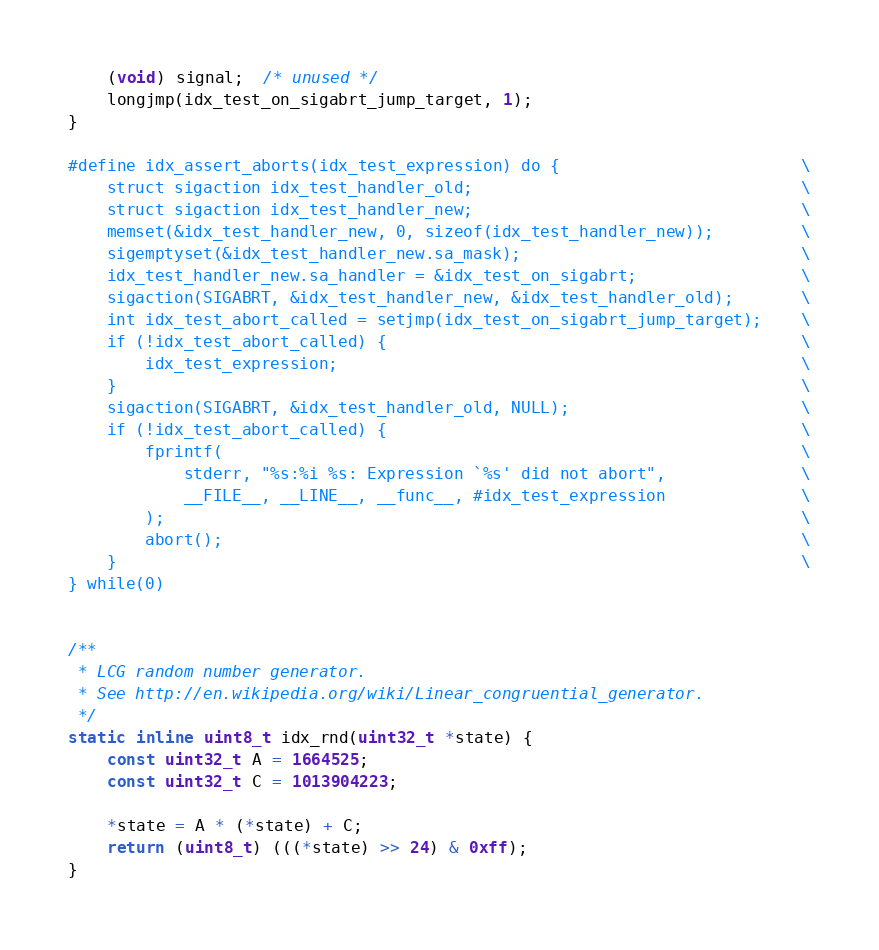<code> <loc_0><loc_0><loc_500><loc_500><_C_>    (void) signal;  /* unused */
    longjmp(idx_test_on_sigabrt_jump_target, 1);
}

#define idx_assert_aborts(idx_test_expression) do {                         \
    struct sigaction idx_test_handler_old;                                  \
    struct sigaction idx_test_handler_new;                                  \
    memset(&idx_test_handler_new, 0, sizeof(idx_test_handler_new));         \
    sigemptyset(&idx_test_handler_new.sa_mask);                             \
    idx_test_handler_new.sa_handler = &idx_test_on_sigabrt;                 \
    sigaction(SIGABRT, &idx_test_handler_new, &idx_test_handler_old);       \
    int idx_test_abort_called = setjmp(idx_test_on_sigabrt_jump_target);    \
    if (!idx_test_abort_called) {                                           \
        idx_test_expression;                                                \
    }                                                                       \
    sigaction(SIGABRT, &idx_test_handler_old, NULL);                        \
    if (!idx_test_abort_called) {                                           \
        fprintf(                                                            \
            stderr, "%s:%i %s: Expression `%s' did not abort",              \
            __FILE__, __LINE__, __func__, #idx_test_expression              \
        );                                                                  \
        abort();                                                            \
    }                                                                       \
} while(0)


/**
 * LCG random number generator.
 * See http://en.wikipedia.org/wiki/Linear_congruential_generator.
 */
static inline uint8_t idx_rnd(uint32_t *state) {
    const uint32_t A = 1664525;
    const uint32_t C = 1013904223;

    *state = A * (*state) + C;
    return (uint8_t) (((*state) >> 24) & 0xff);
}

</code> 